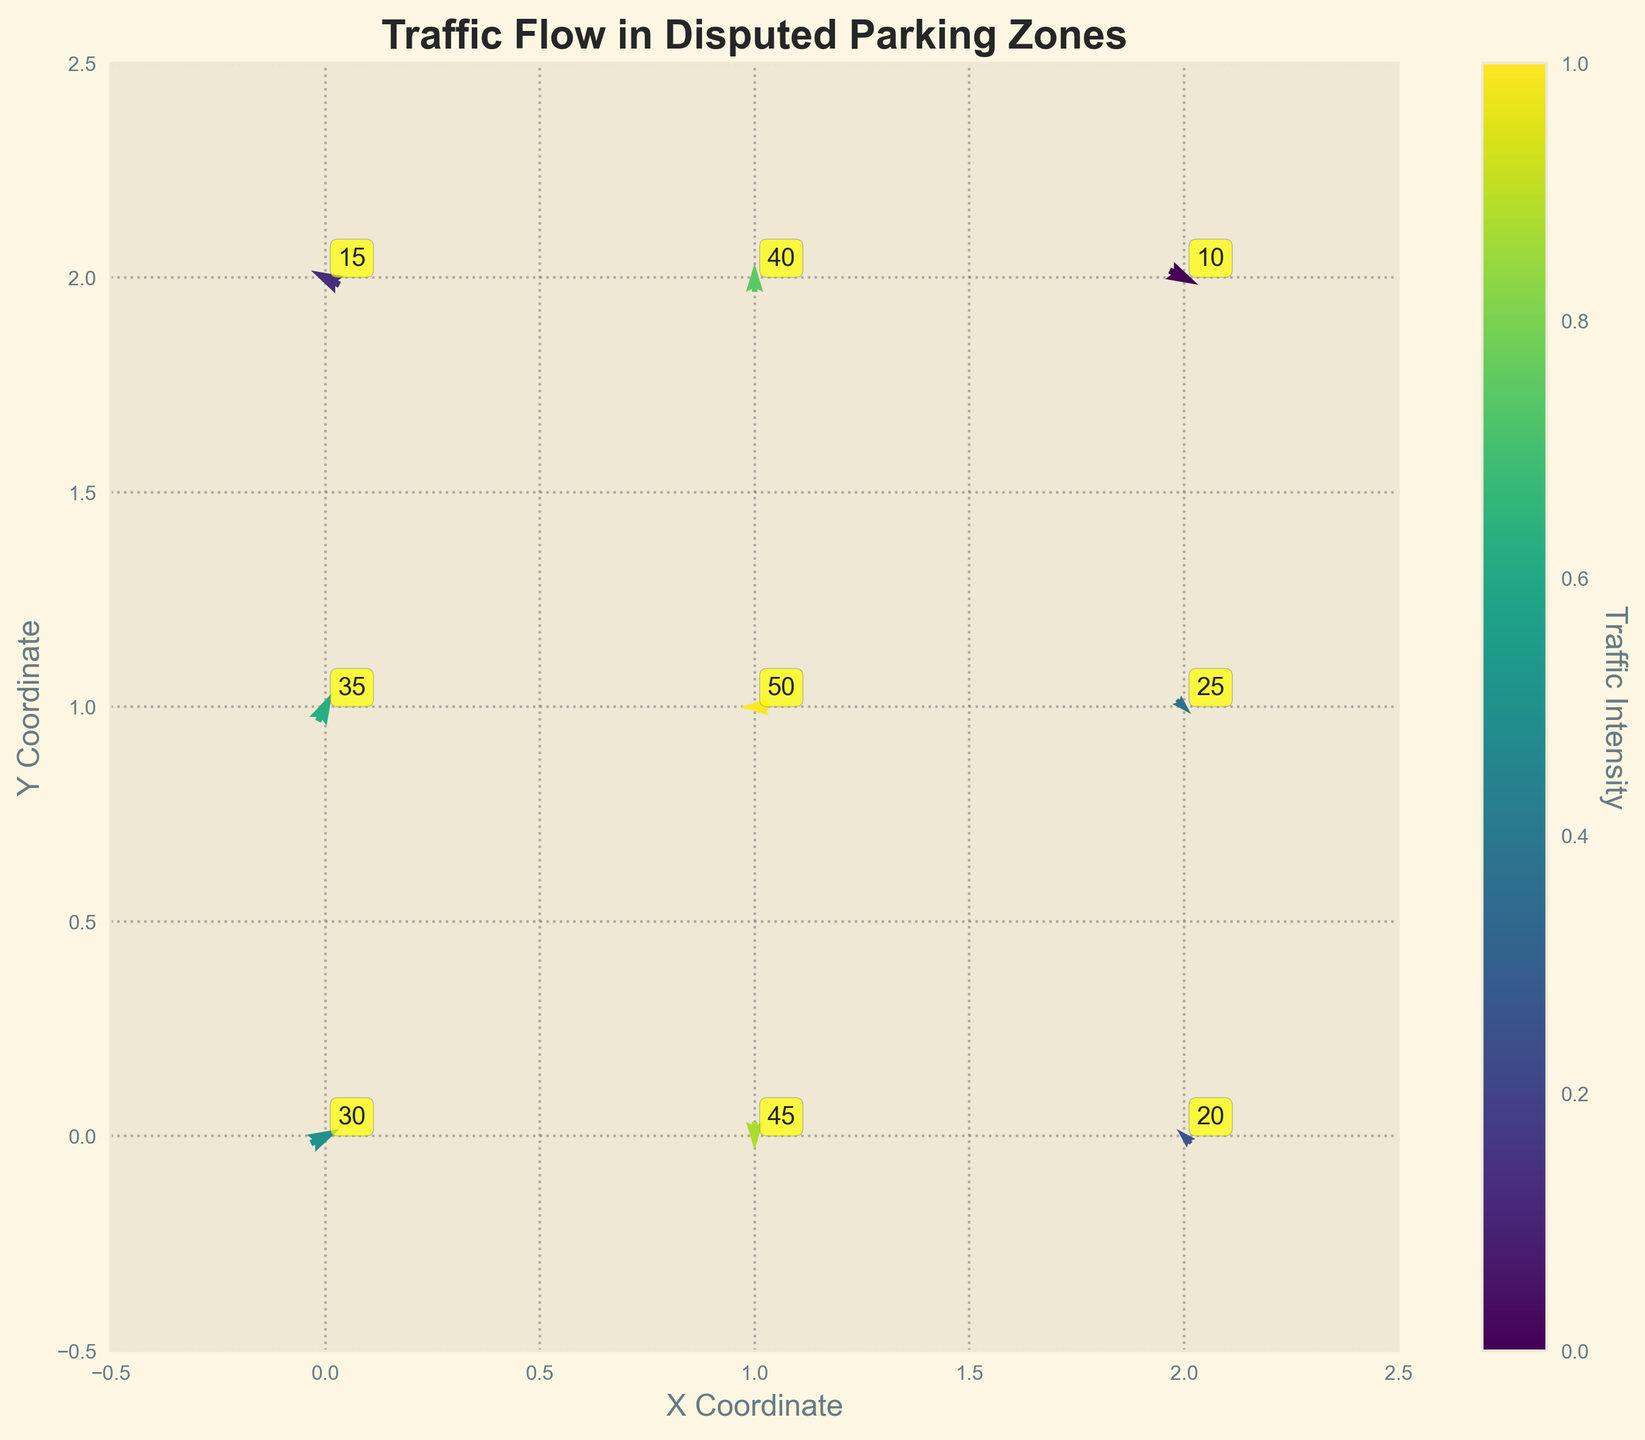What is the title of the plot? The title of the plot is typically found at the top of the figure in bold text. In this case, it is given within the code as `ax.set_title`. The title helps to understand the main purpose of the graph.
Answer: Traffic Flow in Disputed Parking Zones What are the labels of the X and Y axes? The labels of the axes are provided in the code using `ax.set_xlabel` and `ax.set_ylabel`. These labels help to identify the dimensions or variables represented on each axis.
Answer: X Coordinate, Y Coordinate How many data points are included in this plot? By looking at the `x` and `y` coordinates listed in the data, we can count the number of unique coordinates given. Each unique (x, y) pair represents a data point, totaling 9 in this case.
Answer: 9 Which grid point has the highest traffic intensity, and what is its intensity value? The traffic intensity values are annotated on the plot at their respective grid points. The point with the highest value in the `intensity` column of the data, which is 50, appears at the coordinates (1, 1).
Answer: (1, 1) and 50 Compare the traffic intensity at grid point (0, 1) with that at (2, 1). Which one is higher? By checking the intensity values at the specified grid points, one can see that point (0, 1) has an intensity of 35, while point (2, 1) has an intensity of 25. Hence, the intensity at (0, 1) is higher.
Answer: (0, 1) is higher What is the average traffic intensity across all points? To find the average intensity, sum all intensity values (30 + 45 + 20 + 35 + 50 + 25 + 15 + 40 + 10) which equals 270. Then, divide by the number of data points, which is 9.
Answer: 30 Which direction is the flow at point (1, 0) heading? The flow at each point is represented by the (u, v) vector components. At point (1, 0), the vector (0, -1) indicates a downward direction.
Answer: Downward How many vectors are pointing to the left? To determine this, look at the `u` values in the data. If `u` is negative, it indicates leftward direction. Points (2, 0), (1, 1), and (0, 2) have negative `u` values.
Answer: 3 What is the direction and intensity of traffic flow at point (2, 2)? At point (2, 2), the vector (1, -0.5) indicates a direction to the right and slightly downward. The intensity, as annotated, is 10.
Answer: Right and slightly downward, 10 